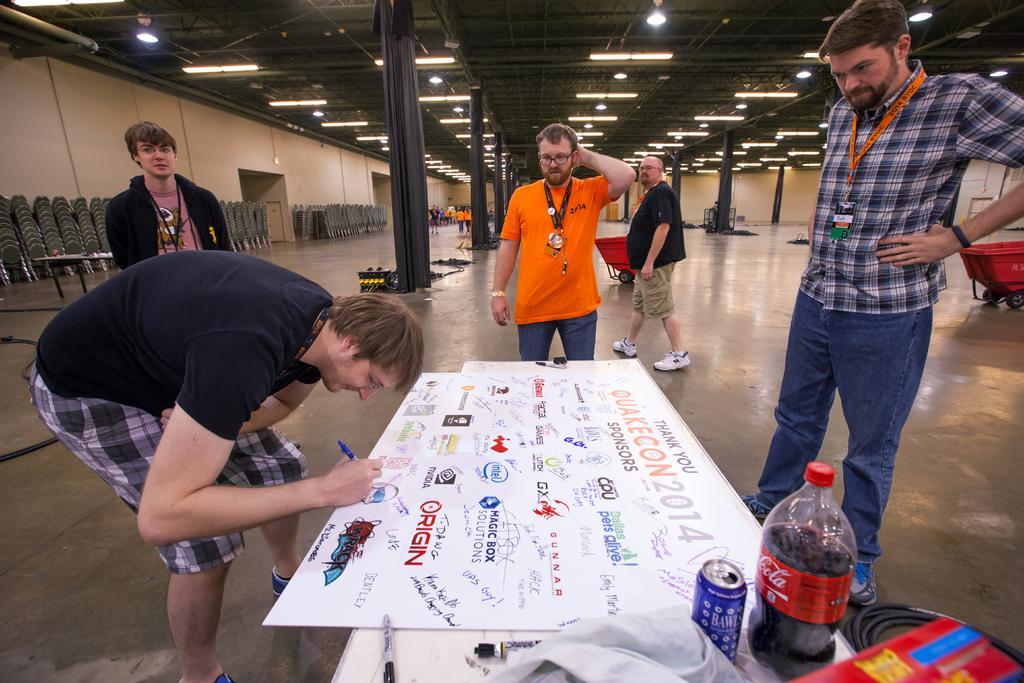Please provide a concise description of this image. In the middle of the image a man is standing and watching. Top right side of the image a man is standing and watching. Left side of the image a man is watching. Bottom left side of the image a man is writing. Bottom of the image there is a table. On the table there is a bottle, Beside the bottle there is a tin. At the top of the image there is a roof and light. In the middle of the image there are some group of people walking, Behind them there is a wall. 